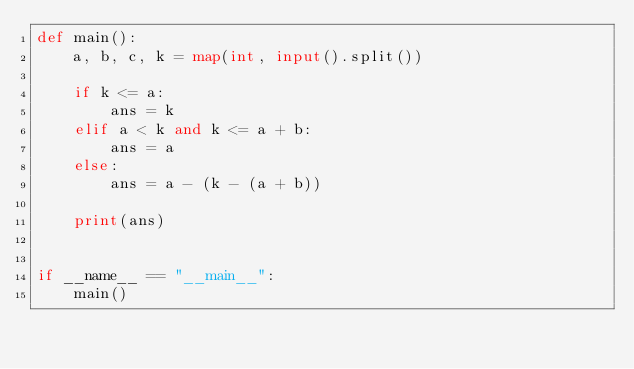<code> <loc_0><loc_0><loc_500><loc_500><_Python_>def main():
    a, b, c, k = map(int, input().split())

    if k <= a:
        ans = k
    elif a < k and k <= a + b:
        ans = a
    else:
        ans = a - (k - (a + b))

    print(ans)


if __name__ == "__main__":
    main()
</code> 